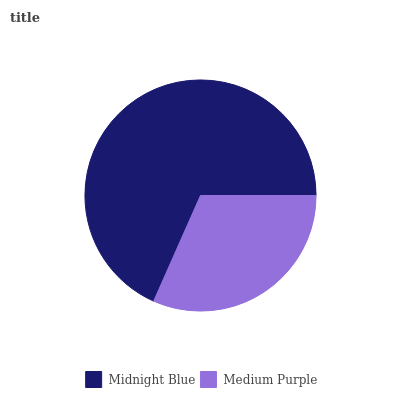Is Medium Purple the minimum?
Answer yes or no. Yes. Is Midnight Blue the maximum?
Answer yes or no. Yes. Is Medium Purple the maximum?
Answer yes or no. No. Is Midnight Blue greater than Medium Purple?
Answer yes or no. Yes. Is Medium Purple less than Midnight Blue?
Answer yes or no. Yes. Is Medium Purple greater than Midnight Blue?
Answer yes or no. No. Is Midnight Blue less than Medium Purple?
Answer yes or no. No. Is Midnight Blue the high median?
Answer yes or no. Yes. Is Medium Purple the low median?
Answer yes or no. Yes. Is Medium Purple the high median?
Answer yes or no. No. Is Midnight Blue the low median?
Answer yes or no. No. 